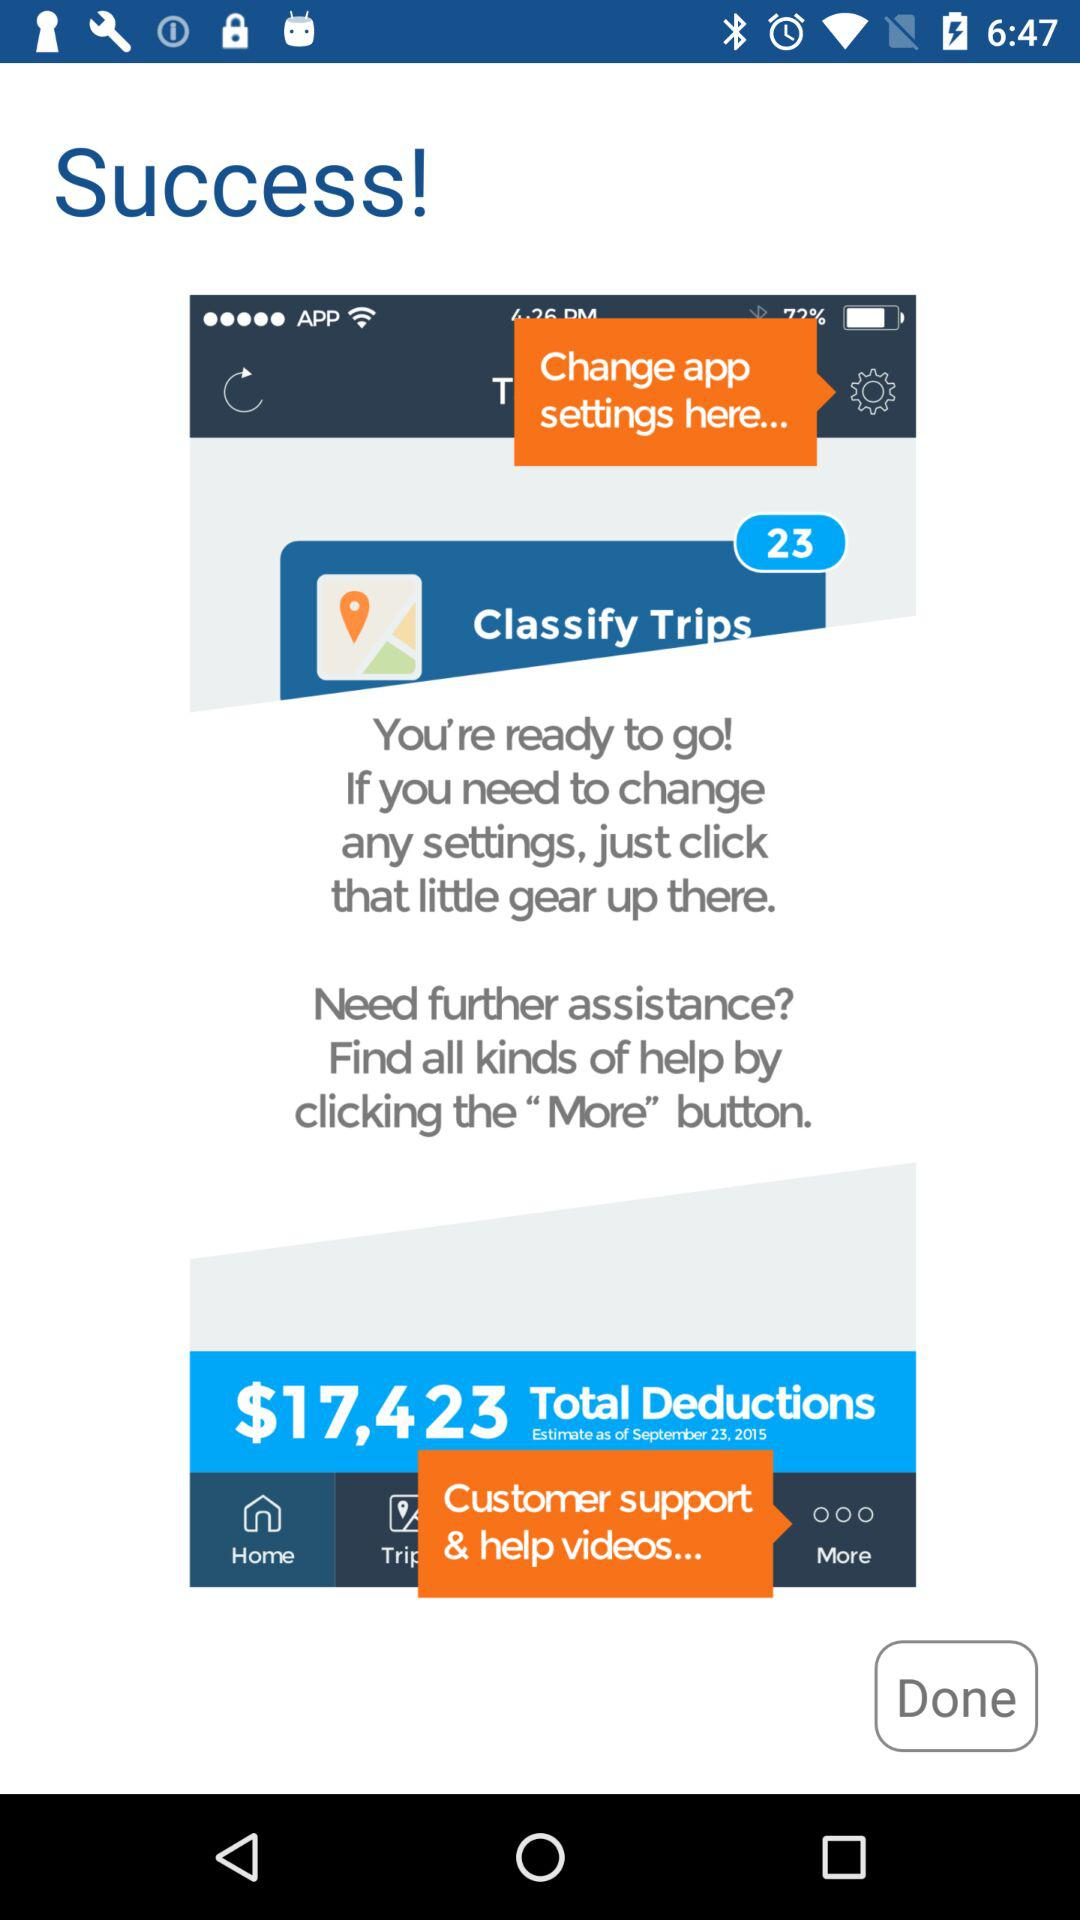What are the total deductions? The total deductions are $17,423. 